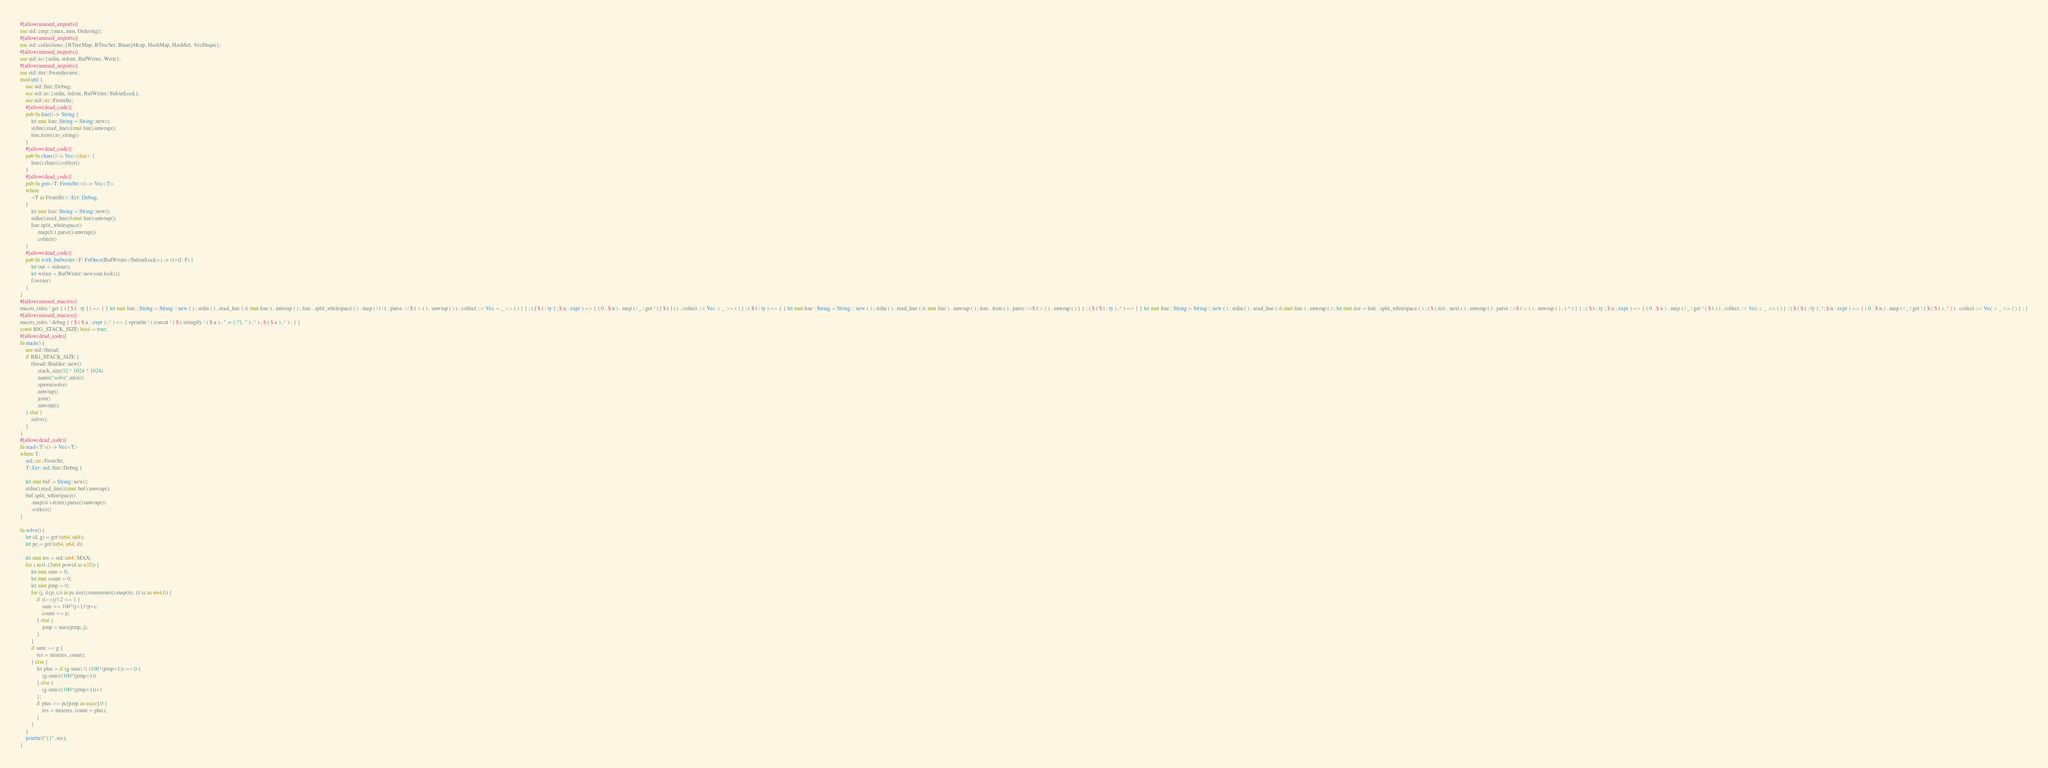Convert code to text. <code><loc_0><loc_0><loc_500><loc_500><_Rust_>#[allow(unused_imports)]
use std::cmp::{max, min, Ordering};
#[allow(unused_imports)]
use std::collections::{BTreeMap, BTreeSet, BinaryHeap, HashMap, HashSet, VecDeque};
#[allow(unused_imports)]
use std::io::{stdin, stdout, BufWriter, Write};
#[allow(unused_imports)]
use std::iter::FromIterator;
mod util {
    use std::fmt::Debug;
    use std::io::{stdin, stdout, BufWriter, StdoutLock};
    use std::str::FromStr;
    #[allow(dead_code)]
    pub fn line() -> String {
        let mut line: String = String::new();
        stdin().read_line(&mut line).unwrap();
        line.trim().to_string()
    }
    #[allow(dead_code)]
    pub fn chars() -> Vec<char> {
        line().chars().collect()
    }
    #[allow(dead_code)]
    pub fn gets<T: FromStr>() -> Vec<T>
    where
        <T as FromStr>::Err: Debug,
    {
        let mut line: String = String::new();
        stdin().read_line(&mut line).unwrap();
        line.split_whitespace()
            .map(|t| t.parse().unwrap())
            .collect()
    }
    #[allow(dead_code)]
    pub fn with_bufwriter<F: FnOnce(BufWriter<StdoutLock>) -> ()>(f: F) {
        let out = stdout();
        let writer = BufWriter::new(out.lock());
        f(writer)
    }
}
#[allow(unused_macros)]
macro_rules ! get { ( [ $ t : ty ] ) => { { let mut line : String = String :: new ( ) ; stdin ( ) . read_line ( & mut line ) . unwrap ( ) ; line . split_whitespace ( ) . map ( | t | t . parse ::<$ t > ( ) . unwrap ( ) ) . collect ::< Vec < _ >> ( ) } } ; ( [ $ t : ty ] ; $ n : expr ) => { ( 0 ..$ n ) . map ( | _ | get ! ( [ $ t ] ) ) . collect ::< Vec < _ >> ( ) } ; ( $ t : ty ) => { { let mut line : String = String :: new ( ) ; stdin ( ) . read_line ( & mut line ) . unwrap ( ) ; line . trim ( ) . parse ::<$ t > ( ) . unwrap ( ) } } ; ( $ ( $ t : ty ) ,* ) => { { let mut line : String = String :: new ( ) ; stdin ( ) . read_line ( & mut line ) . unwrap ( ) ; let mut iter = line . split_whitespace ( ) ; ( $ ( iter . next ( ) . unwrap ( ) . parse ::<$ t > ( ) . unwrap ( ) , ) * ) } } ; ( $ t : ty ; $ n : expr ) => { ( 0 ..$ n ) . map ( | _ | get ! ( $ t ) ) . collect ::< Vec < _ >> ( ) } ; ( $ ( $ t : ty ) ,*; $ n : expr ) => { ( 0 ..$ n ) . map ( | _ | get ! ( $ ( $ t ) ,* ) ) . collect ::< Vec < _ >> ( ) } ; }
#[allow(unused_macros)]
macro_rules ! debug { ( $ ( $ a : expr ) ,* ) => { eprintln ! ( concat ! ( $ ( stringify ! ( $ a ) , " = {:?}, " ) ,* ) , $ ( $ a ) ,* ) ; } }
const BIG_STACK_SIZE: bool = true;
#[allow(dead_code)]
fn main() {
    use std::thread;
    if BIG_STACK_SIZE {
        thread::Builder::new()
            .stack_size(32 * 1024 * 1024)
            .name("solve".into())
            .spawn(solve)
            .unwrap()
            .join()
            .unwrap();
    } else {
        solve();
    }
}
#[allow(dead_code)]
fn read<T>() -> Vec<T>
where T:
    std::str::FromStr,
    T::Err: std::fmt::Debug {

    let mut buf = String::new();
    stdin().read_line(&mut buf).unwrap();
    buf.split_whitespace()
        .map(|s| s.trim().parse().unwrap())
        .collect()
}

fn solve() {
    let (d, g) = get!(u64, u64);
    let pc = get!(u64, u64; d);

    let mut res = std::u64::MAX;
    for i in 0..(2u64.pow(d as u32)) {
        let mut sum = 0;
        let mut count = 0;
        let mut jtmp = 0;
        for (j, &(p, c)) in pc.iter().enumerate().map(|(e, t)| (e as u64,t)) {
            if (i>>j)%2 == 1 {
                sum += 100*(j+1)*p+c;
                count += p;
            } else {
                jtmp = max(jtmp, j);
            }
        }
        if sum >= g {
            res = min(res, count);
        } else {
            let plus = if (g-sum) % (100*(jtmp+1)) == 0 {
                (g-sum)/(100*(jtmp+1))
            } else {
                (g-sum)/(100*(jtmp+1))+1
            };
            if plus <= pc[jtmp as usize].0 {
                res = min(res, count + plus);
            }
        }
    }
    println!("{}", res);
}
</code> 